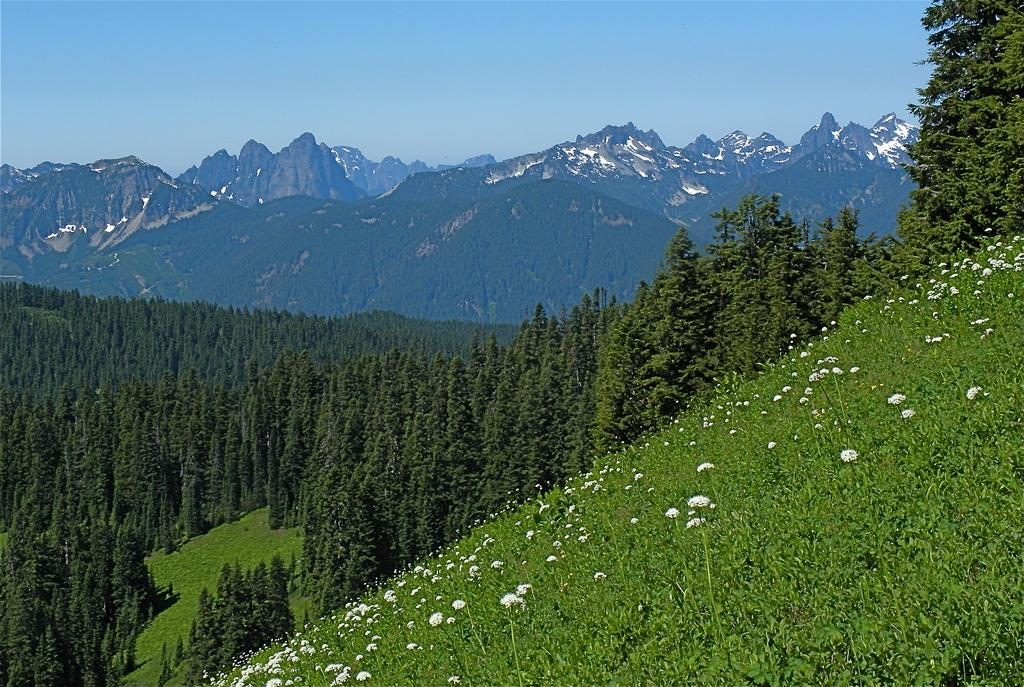What type of vegetation can be seen in the image? There are flowers, plants, and trees in the image. What natural feature is visible in the background of the image? There are mountains in the image. What part of the natural environment is visible in the image? The sky is visible in the image. What type of tin can be seen in the image? There is no tin present in the image. What tool is being used to tighten or loosen something in the image? There is no tool or wrench present in the image. 